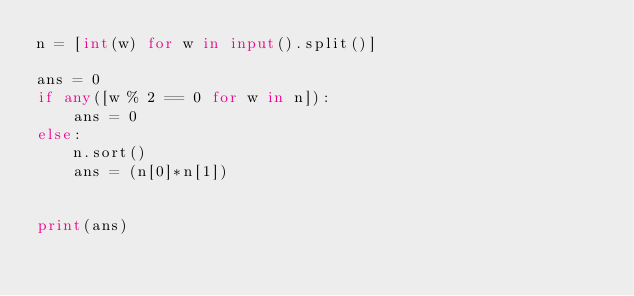Convert code to text. <code><loc_0><loc_0><loc_500><loc_500><_Python_>n = [int(w) for w in input().split()]

ans = 0
if any([w % 2 == 0 for w in n]):
    ans = 0
else:
    n.sort()
    ans = (n[0]*n[1])


print(ans)
</code> 